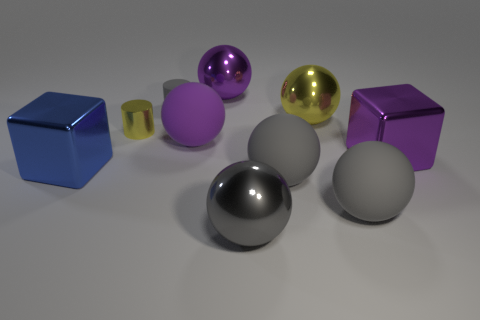The metallic thing that is the same color as the rubber cylinder is what shape?
Give a very brief answer. Sphere. How many other objects are the same size as the gray rubber cylinder?
Offer a very short reply. 1. There is a shiny ball that is in front of the big purple cube; is it the same size as the purple metallic object that is left of the yellow metal sphere?
Your answer should be very brief. Yes. What number of objects are either big blue objects or metallic objects on the right side of the tiny matte cylinder?
Keep it short and to the point. 5. There is a metallic ball that is behind the large yellow thing; what is its size?
Ensure brevity in your answer.  Large. Is the number of small gray things in front of the blue cube less than the number of shiny balls that are behind the purple matte ball?
Give a very brief answer. Yes. What is the thing that is behind the metal cylinder and on the left side of the purple metal ball made of?
Offer a terse response. Rubber. There is a tiny thing to the right of the small thing that is left of the tiny gray thing; what shape is it?
Your answer should be very brief. Cylinder. Is the color of the small shiny cylinder the same as the small rubber thing?
Provide a succinct answer. No. How many purple objects are big balls or large metal balls?
Ensure brevity in your answer.  2. 